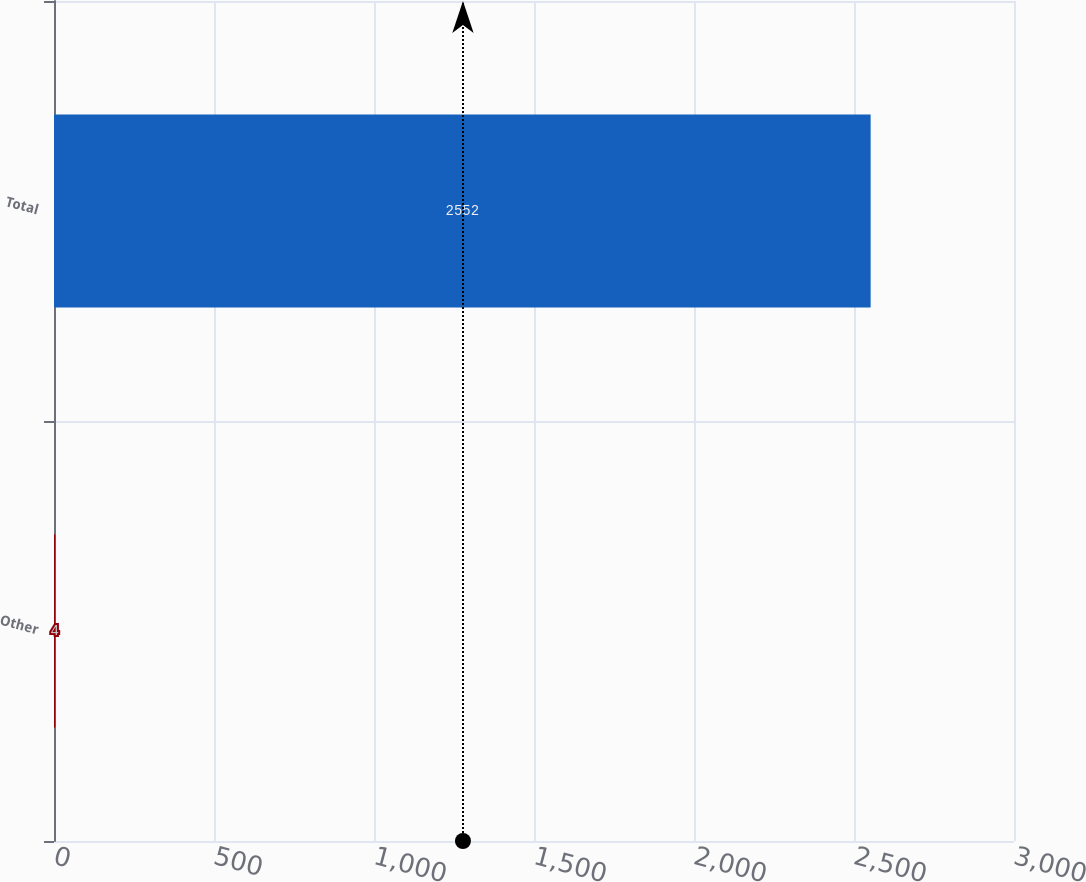Convert chart. <chart><loc_0><loc_0><loc_500><loc_500><bar_chart><fcel>Other<fcel>Total<nl><fcel>4<fcel>2552<nl></chart> 